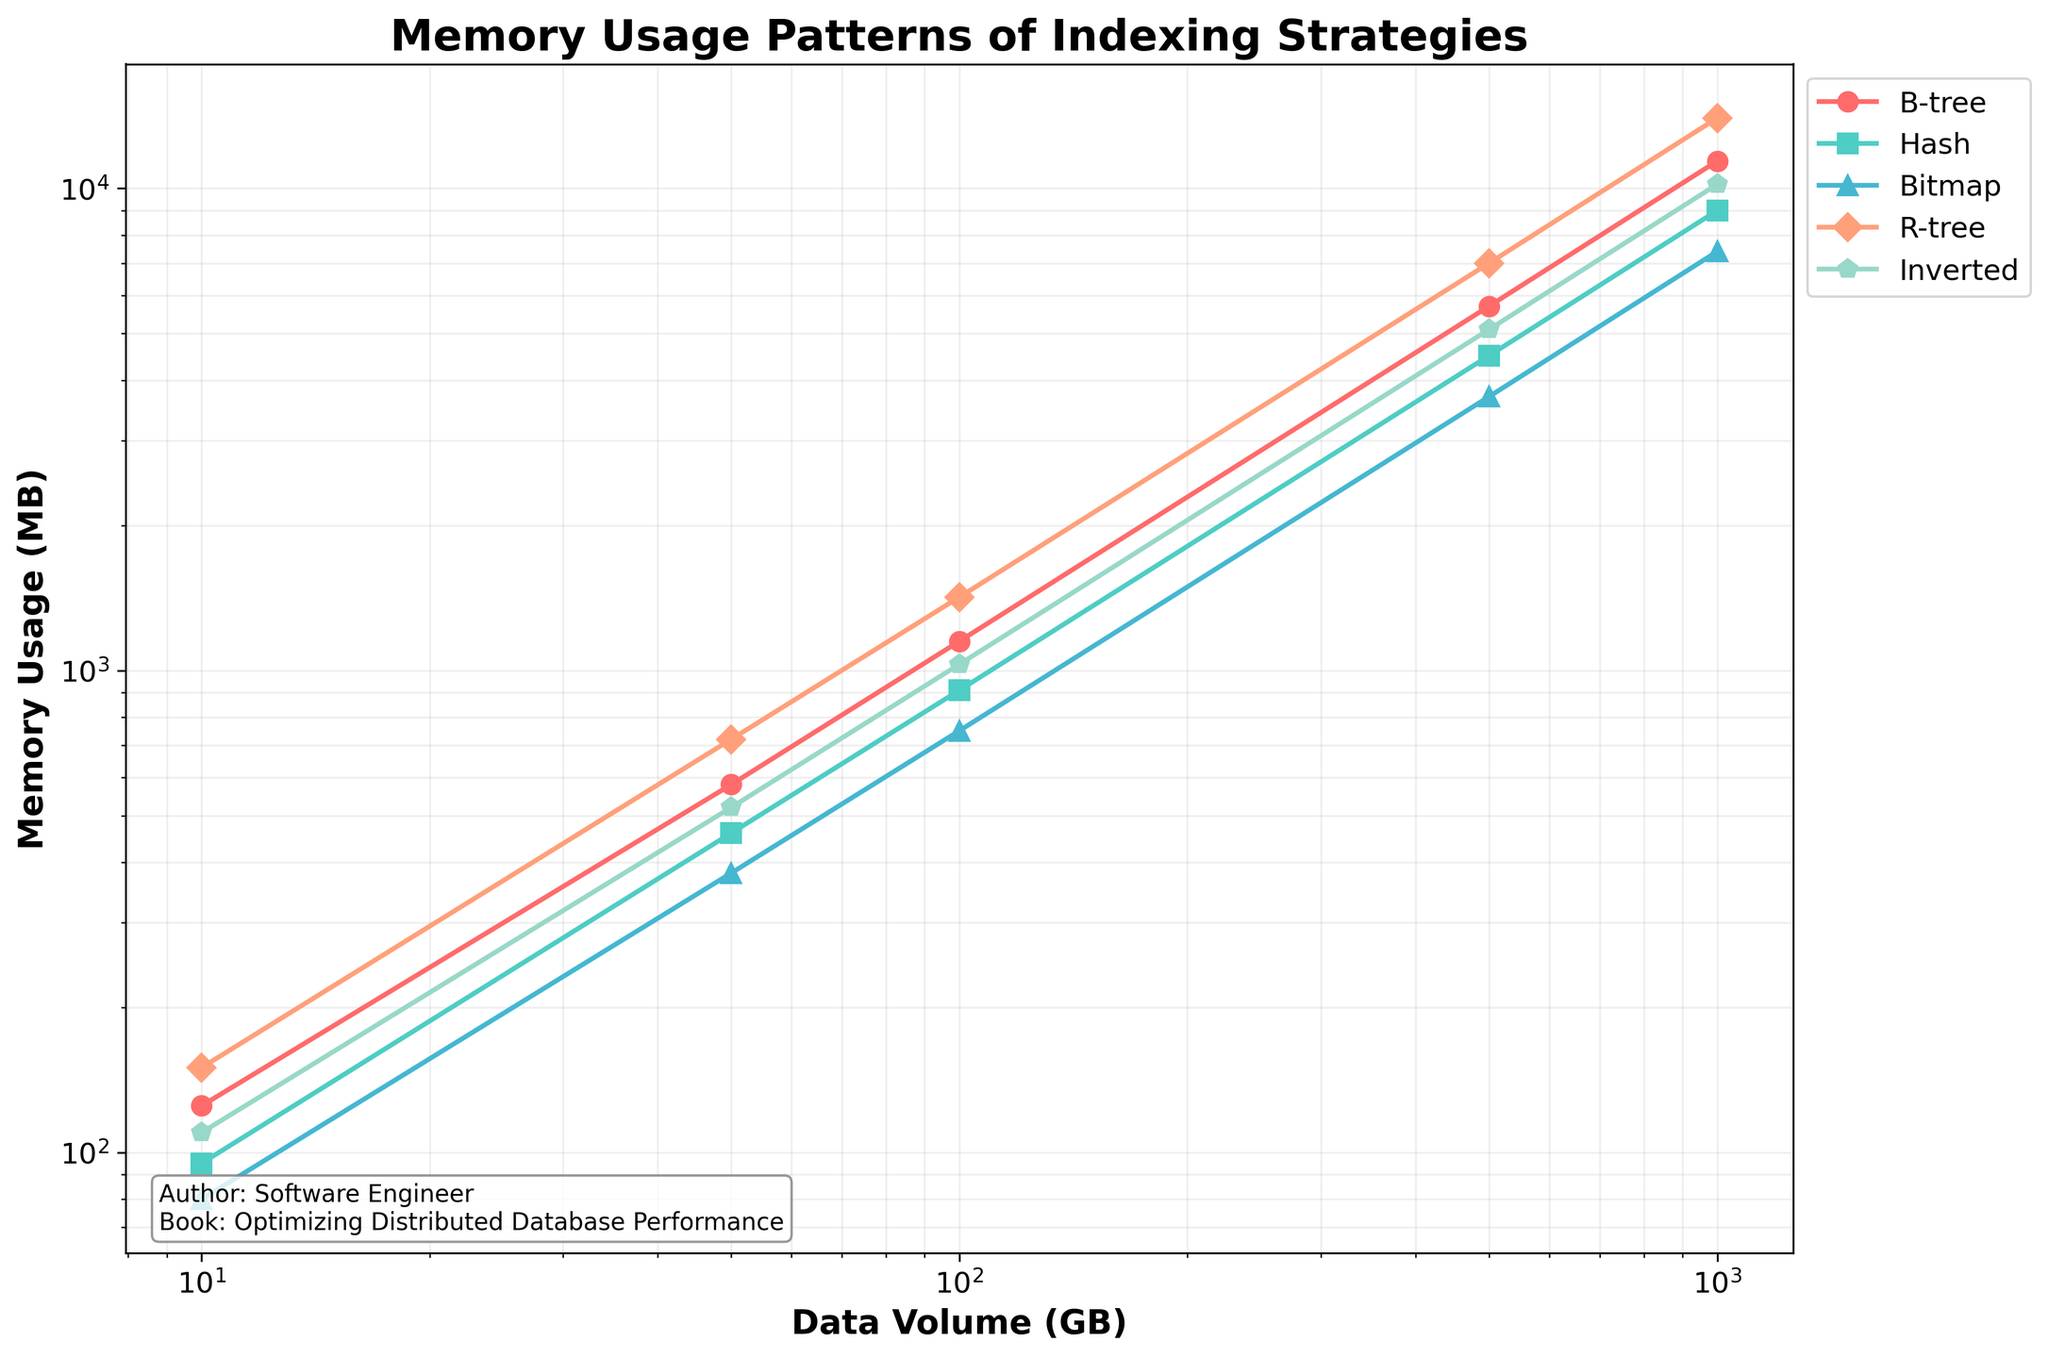What is the memory usage of the Hash index when the data volume is 500 GB? From the figure, find the data point corresponding to the Hash index at 500 GB of data volume, which shows the memory usage.
Answer: 4500 MB Which indexing strategy has the highest memory usage at 1000 GB of data volume? Compare the memory usage of all indexing strategies at 1000 GB of data volume by looking at the data points for each index. The highest one can be identified visually.
Answer: R-tree How does the memory usage of the Bitmap index at 100 GB compare to the Inverted index at the same data volume? Locate the memory usage data points for both Bitmap and Inverted indices at 100 GB of data volume and compare them.
Answer: Bitmap uses 750 MB, Inverted uses 1030 MB, Bitmap is lower What is the difference in memory usage between the B-tree and Hash index at 50 GB data volume? Check the memory usage values for B-tree and Hash indices at 50 GB. Subtract the smaller value from the larger one to get the difference.
Answer: 120 MB Which index type consistently shows the lowest memory usage as data volume increases? Observe the overall trend of memory usage for all index types across different data volumes and identify which line is consistently at the lowest position.
Answer: Bitmap What is the average memory usage of the R-tree index across all data volumes shown? First, find the memory usage values for the R-tree index at all data volumes. Then calculate the average by summing these values and dividing by the number of data points (5).
Answer: (150 + 720 + 1420 + 7000 + 14000) / 5 = 4682 MB How does the scaling pattern of the B-tree index compare to the Inverted index over increasing data volumes? Visually compare the slopes of the B-tree and Inverted index lines on the log-log plot. The steeper the slope, the faster the memory usage grows with data volume.
Answer: B-tree and Inverted have roughly similar scaling patterns, both increasing linearly on the log-log scale What is the combined memory usage of Hash and Bitmap indices at 10 GB of data volume? Add the memory usage values of Hash and Bitmap indices at 10 GB of data volume.
Answer: 95 MB (Hash) + 80 MB (Bitmap) = 175 MB At 500 GB, which index strategy shows a midpoint between the highest and lowest memory usage values? Identify the highest and lowest memory usage values at 500 GB, find their midpoint, and see which index has a memory usage closest to this midpoint.
Answer: The midpoint between 3700 MB and 7000 MB is 5350 MB, closest to Inverted (5100 MB) 